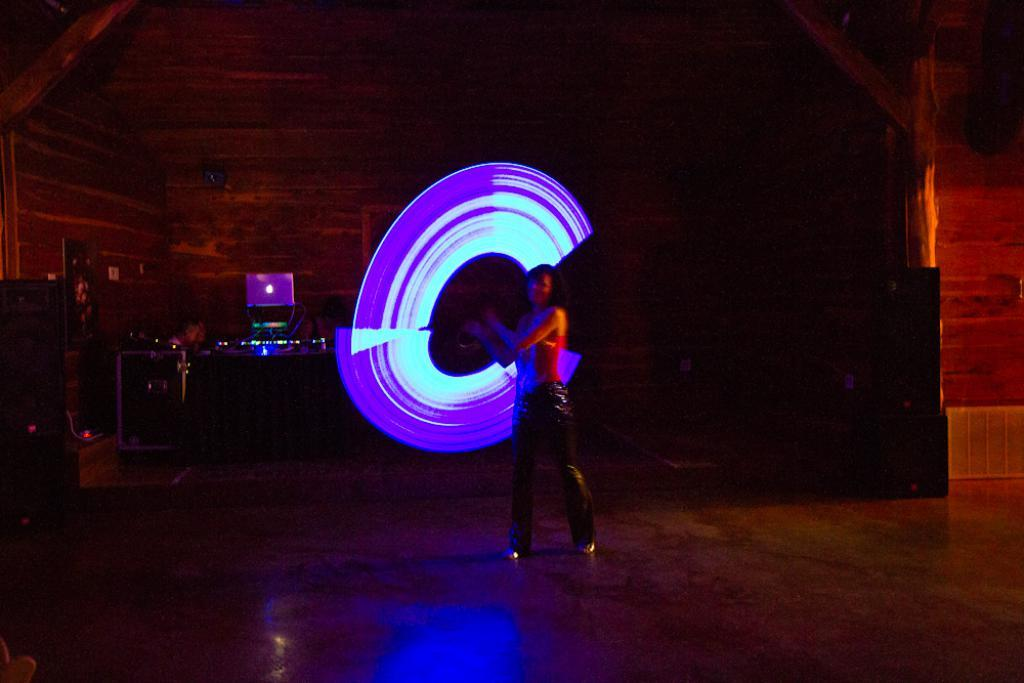Who or what is present in the image? There is a person in the image. What is the person's position or location in the image? The person is on a surface in the image. What type of lighting can be seen in the image? There is neon light in the image. What else can be seen on the left side of the image? Electronic devices are visible on the left side of the image. What is the effect of the neon light on the nation in the image? There is no nation present in the image, and the neon light does not have any effect on a nation. 